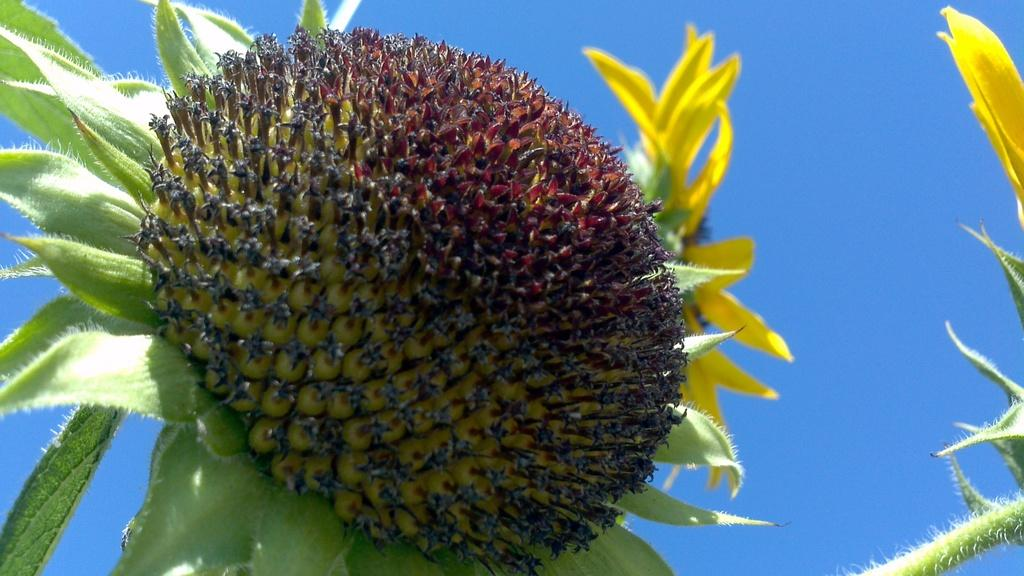What is the main subject of the image? There is a flower in the image. What color are the petals of the flower? The flower has yellow petals. What can be seen in the background of the image? The sky is visible at the top of the image. Can you see a hole in the flower in the image? There is no hole visible in the flower in the image. What type of whistle is being used by the flower in the image? There is no whistle present in the image; it features a flower with yellow petals and a visible sky in the background. 